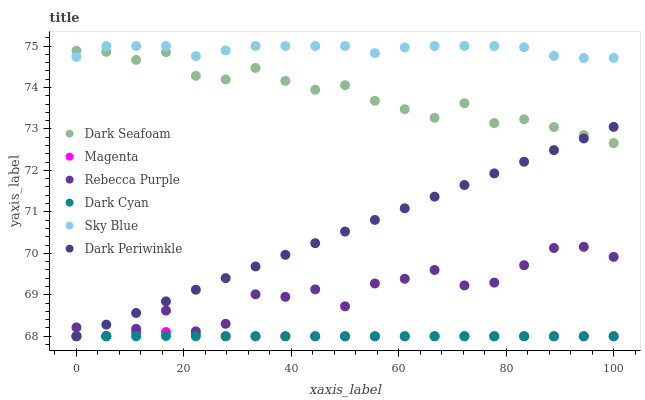Does Dark Cyan have the minimum area under the curve?
Answer yes or no. Yes. Does Sky Blue have the maximum area under the curve?
Answer yes or no. Yes. Does Rebecca Purple have the minimum area under the curve?
Answer yes or no. No. Does Rebecca Purple have the maximum area under the curve?
Answer yes or no. No. Is Dark Periwinkle the smoothest?
Answer yes or no. Yes. Is Rebecca Purple the roughest?
Answer yes or no. Yes. Is Dark Cyan the smoothest?
Answer yes or no. No. Is Dark Cyan the roughest?
Answer yes or no. No. Does Rebecca Purple have the lowest value?
Answer yes or no. Yes. Does Sky Blue have the lowest value?
Answer yes or no. No. Does Sky Blue have the highest value?
Answer yes or no. Yes. Does Rebecca Purple have the highest value?
Answer yes or no. No. Is Magenta less than Sky Blue?
Answer yes or no. Yes. Is Sky Blue greater than Rebecca Purple?
Answer yes or no. Yes. Does Dark Periwinkle intersect Dark Cyan?
Answer yes or no. Yes. Is Dark Periwinkle less than Dark Cyan?
Answer yes or no. No. Is Dark Periwinkle greater than Dark Cyan?
Answer yes or no. No. Does Magenta intersect Sky Blue?
Answer yes or no. No. 